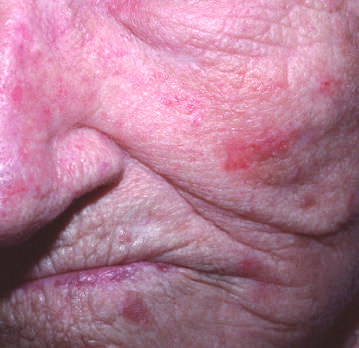re lesions owing to excessive scale present on the cheek and nose?
Answer the question using a single word or phrase. Yes 